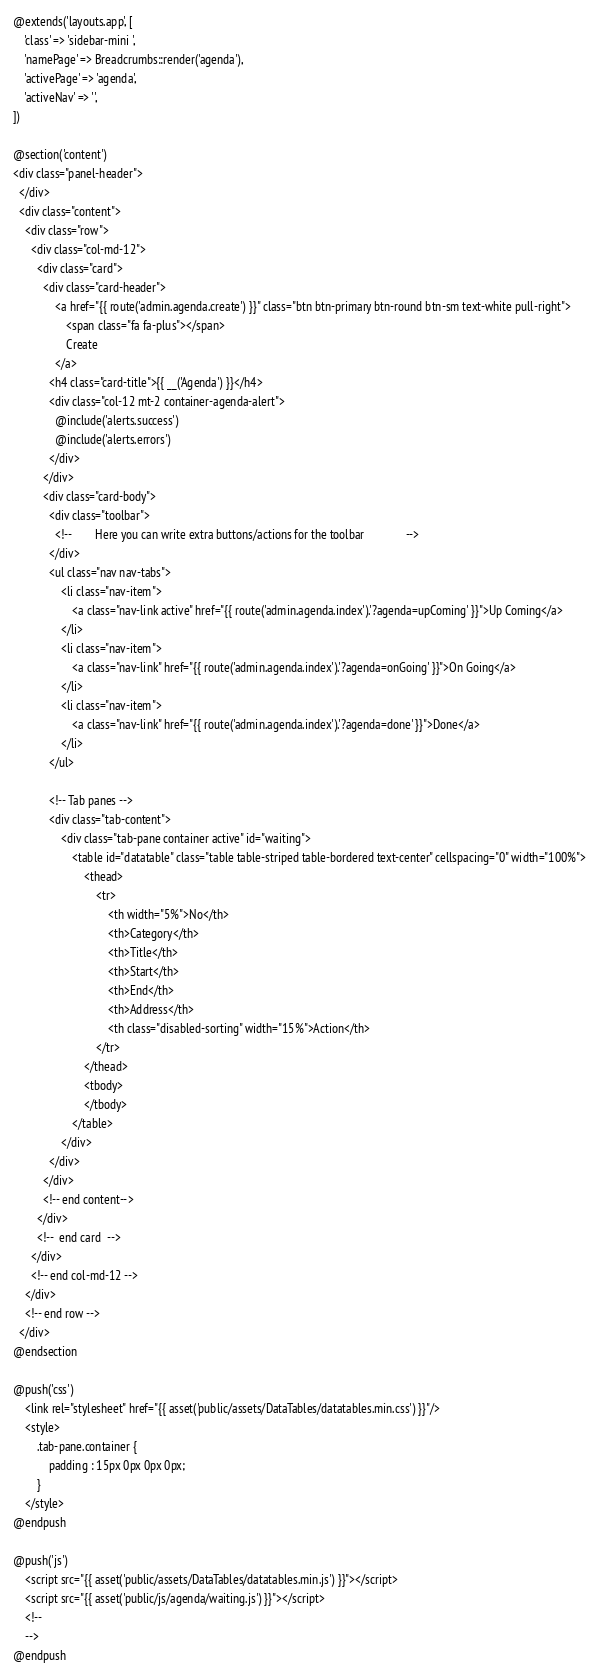<code> <loc_0><loc_0><loc_500><loc_500><_PHP_>@extends('layouts.app', [
    'class' => 'sidebar-mini ',
    'namePage' => Breadcrumbs::render('agenda'),
    'activePage' => 'agenda', 
    'activeNav' => '',
])
 
@section('content')
<div class="panel-header">  
  </div>
  <div class="content">
    <div class="row">
      <div class="col-md-12">
        <div class="card">
          <div class="card-header">
              <a href="{{ route('admin.agenda.create') }}" class="btn btn-primary btn-round btn-sm text-white pull-right">
				  <span class="fa fa-plus"></span>
                  Create
              </a>
            <h4 class="card-title">{{ __('Agenda') }}</h4>
            <div class="col-12 mt-2 container-agenda-alert">
              @include('alerts.success')
              @include('alerts.errors')
            </div>
          </div>
          <div class="card-body">
            <div class="toolbar">
              <!--        Here you can write extra buttons/actions for the toolbar              -->
            </div>
			<ul class="nav nav-tabs">
				<li class="nav-item">
					<a class="nav-link active" href="{{ route('admin.agenda.index').'?agenda=upComing' }}">Up Coming</a>
				</li>
				<li class="nav-item">
					<a class="nav-link" href="{{ route('admin.agenda.index').'?agenda=onGoing' }}">On Going</a>
				</li>
				<li class="nav-item">
					<a class="nav-link" href="{{ route('admin.agenda.index').'?agenda=done' }}">Done</a>
				</li>
			</ul>

			<!-- Tab panes -->
			<div class="tab-content">
				<div class="tab-pane container active" id="waiting">
					<table id="datatable" class="table table-striped table-bordered text-center" cellspacing="0" width="100%">
						<thead>
							<tr>
								<th width="5%">No</th>
								<th>Category</th>
								<th>Title</th>
								<th>Start</th>
								<th>End</th>
								<th>Address</th>
								<th class="disabled-sorting" width="15%">Action</th>
							</tr>
						</thead>
						<tbody>
						</tbody>
					</table>
				</div>
			</div>
          </div>
          <!-- end content-->
        </div>
        <!--  end card  -->
      </div>
      <!-- end col-md-12 -->
    </div>
    <!-- end row -->
  </div>
@endsection

@push('css')
	<link rel="stylesheet" href="{{ asset('public/assets/DataTables/datatables.min.css') }}"/>
	<style>
		.tab-pane.container {
			padding : 15px 0px 0px 0px;
		}
	</style>
@endpush 

@push('js')
	<script src="{{ asset('public/assets/DataTables/datatables.min.js') }}"></script>
	<script src="{{ asset('public/js/agenda/waiting.js') }}"></script>
	<!--
	-->
@endpush</code> 